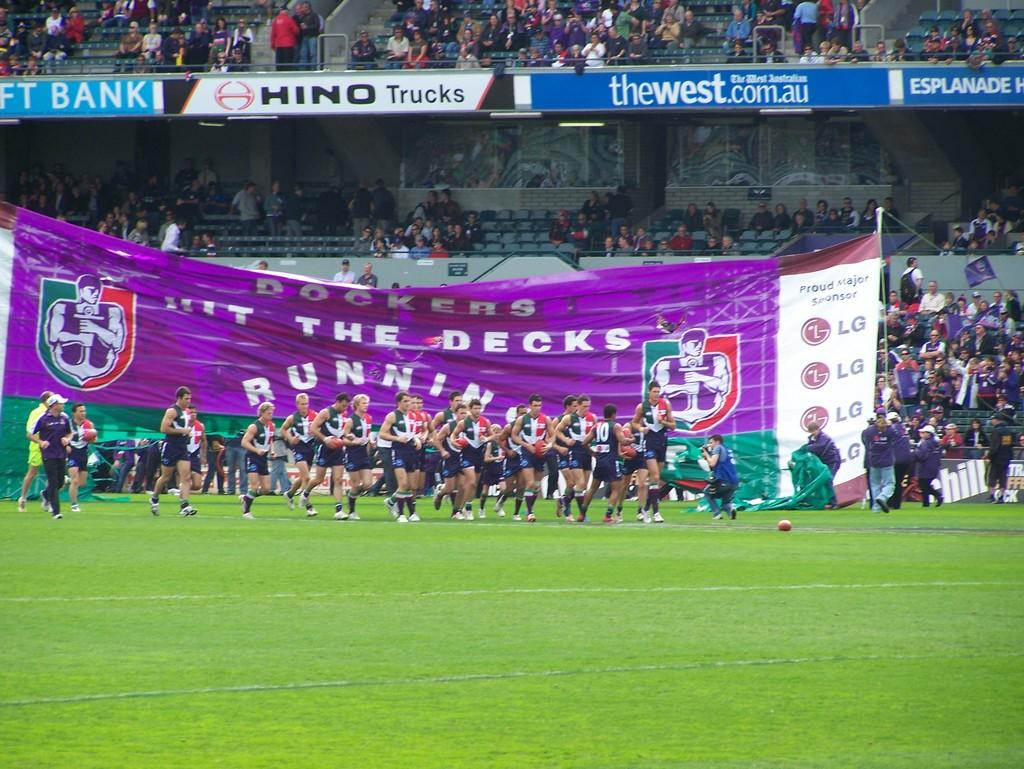<image>
Offer a succinct explanation of the picture presented. Sports venue with a large purple banner marked Dockers Hit the decks running. 